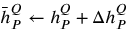Convert formula to latex. <formula><loc_0><loc_0><loc_500><loc_500>\begin{array} { r } { \bar { h } _ { P } ^ { Q } \leftarrow h _ { P } ^ { Q } + \Delta h _ { P } ^ { Q } } \end{array}</formula> 